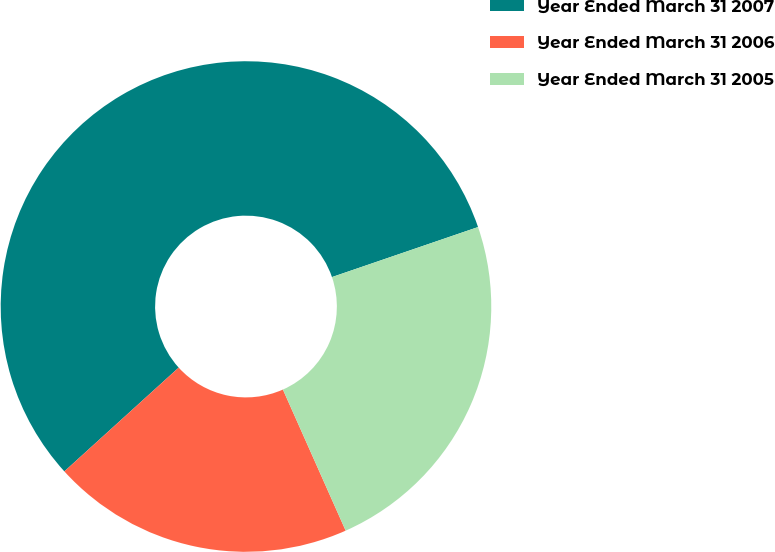<chart> <loc_0><loc_0><loc_500><loc_500><pie_chart><fcel>Year Ended March 31 2007<fcel>Year Ended March 31 2006<fcel>Year Ended March 31 2005<nl><fcel>56.48%<fcel>19.93%<fcel>23.59%<nl></chart> 